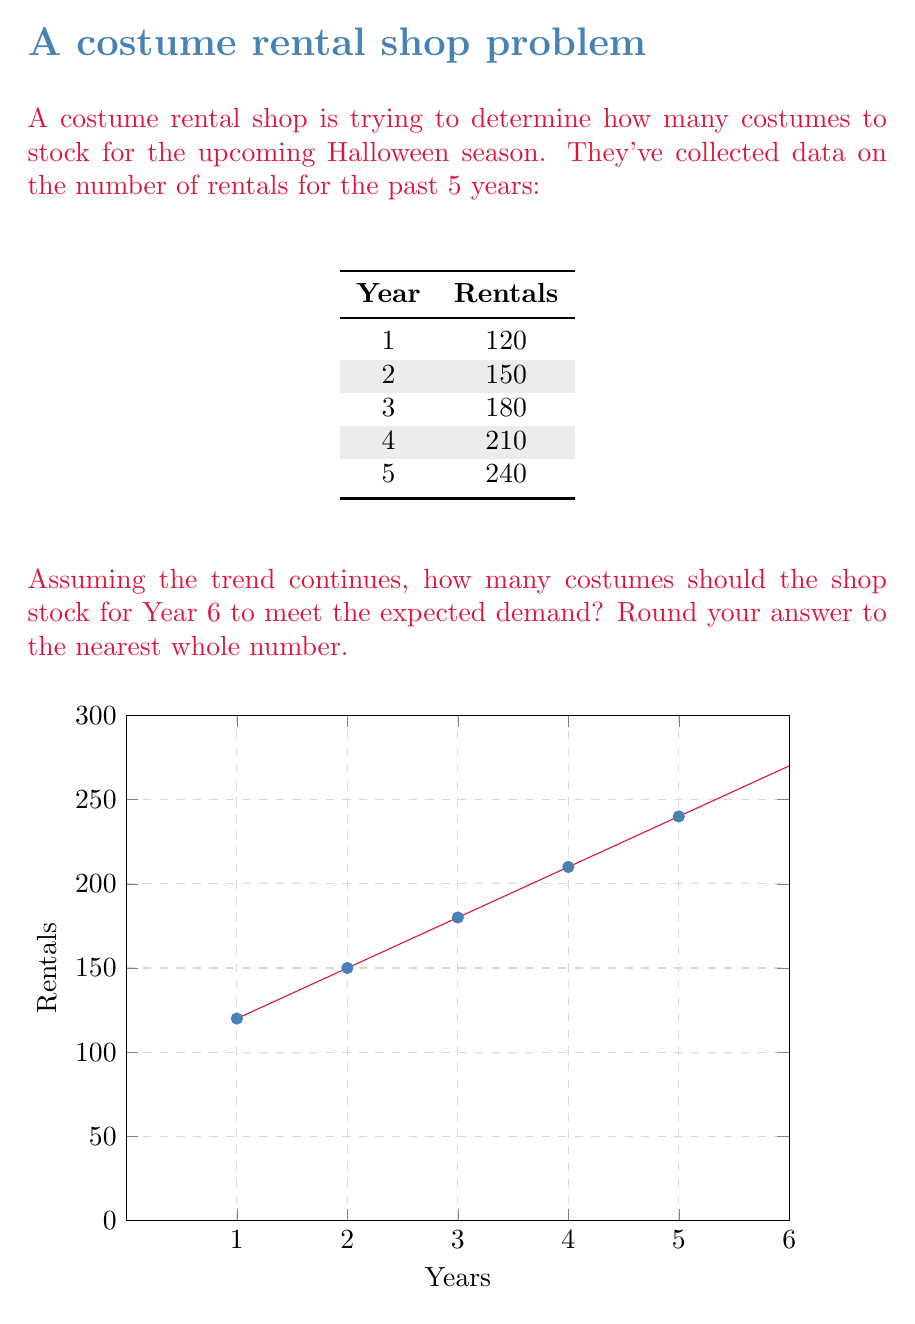Can you solve this math problem? To solve this problem, we need to find the trend in the rental data and extrapolate it to Year 6. Let's approach this step-by-step:

1) First, let's calculate the year-over-year increase:
   Year 2 - Year 1: 150 - 120 = 30
   Year 3 - Year 2: 180 - 150 = 30
   Year 4 - Year 3: 210 - 180 = 30
   Year 5 - Year 4: 240 - 210 = 30

2) We can see that the number of rentals increases by 30 each year. This is an arithmetic sequence with a common difference of 30.

3) We can represent this sequence with the formula:
   $$a_n = a_1 + (n-1)d$$
   Where $a_n$ is the number of rentals in year $n$, $a_1$ is the initial number of rentals (120), and $d$ is the common difference (30).

4) For Year 6, we have:
   $$a_6 = 120 + (6-1)30$$
   $$a_6 = 120 + 5(30)$$
   $$a_6 = 120 + 150 = 270$$

5) Therefore, based on the trend, we expect 270 rentals in Year 6.

6) Rounding to the nearest whole number is not necessary in this case as we already have a whole number.

To meet the expected demand, the shop should stock at least 270 costumes for Year 6.
Answer: 270 costumes 